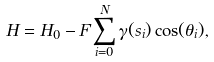Convert formula to latex. <formula><loc_0><loc_0><loc_500><loc_500>H = H _ { 0 } - F \sum ^ { N } _ { i = 0 } \gamma ( s _ { i } ) \cos ( \theta _ { i } ) ,</formula> 